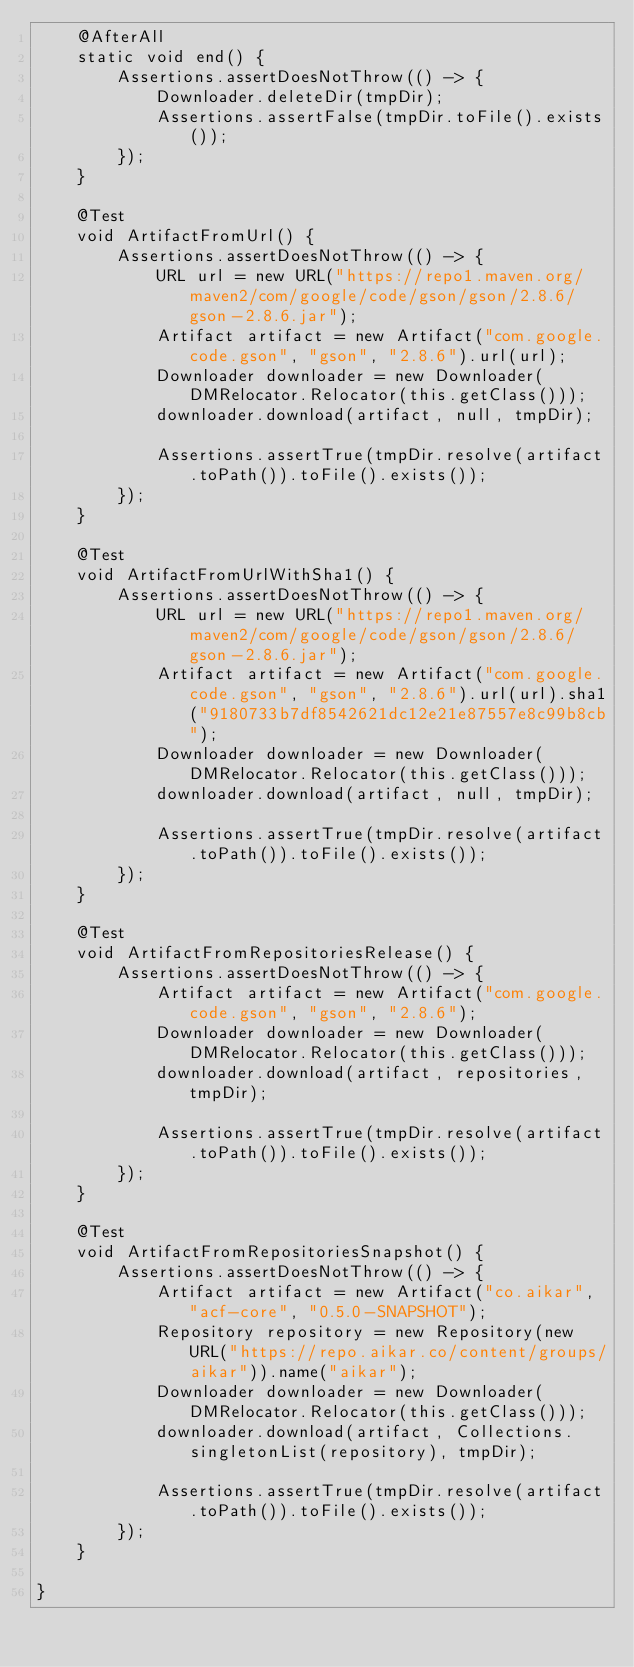<code> <loc_0><loc_0><loc_500><loc_500><_Java_>    @AfterAll
    static void end() {
        Assertions.assertDoesNotThrow(() -> {
            Downloader.deleteDir(tmpDir);
            Assertions.assertFalse(tmpDir.toFile().exists());
        });
    }

    @Test
    void ArtifactFromUrl() {
        Assertions.assertDoesNotThrow(() -> {
            URL url = new URL("https://repo1.maven.org/maven2/com/google/code/gson/gson/2.8.6/gson-2.8.6.jar");
            Artifact artifact = new Artifact("com.google.code.gson", "gson", "2.8.6").url(url);
            Downloader downloader = new Downloader(DMRelocator.Relocator(this.getClass()));
            downloader.download(artifact, null, tmpDir);

            Assertions.assertTrue(tmpDir.resolve(artifact.toPath()).toFile().exists());
        });
    }

    @Test
    void ArtifactFromUrlWithSha1() {
        Assertions.assertDoesNotThrow(() -> {
            URL url = new URL("https://repo1.maven.org/maven2/com/google/code/gson/gson/2.8.6/gson-2.8.6.jar");
            Artifact artifact = new Artifact("com.google.code.gson", "gson", "2.8.6").url(url).sha1("9180733b7df8542621dc12e21e87557e8c99b8cb");
            Downloader downloader = new Downloader(DMRelocator.Relocator(this.getClass()));
            downloader.download(artifact, null, tmpDir);

            Assertions.assertTrue(tmpDir.resolve(artifact.toPath()).toFile().exists());
        });
    }

    @Test
    void ArtifactFromRepositoriesRelease() {
        Assertions.assertDoesNotThrow(() -> {
            Artifact artifact = new Artifact("com.google.code.gson", "gson", "2.8.6");
            Downloader downloader = new Downloader(DMRelocator.Relocator(this.getClass()));
            downloader.download(artifact, repositories, tmpDir);

            Assertions.assertTrue(tmpDir.resolve(artifact.toPath()).toFile().exists());
        });
    }

    @Test
    void ArtifactFromRepositoriesSnapshot() {
        Assertions.assertDoesNotThrow(() -> {
            Artifact artifact = new Artifact("co.aikar", "acf-core", "0.5.0-SNAPSHOT");
            Repository repository = new Repository(new URL("https://repo.aikar.co/content/groups/aikar")).name("aikar");
            Downloader downloader = new Downloader(DMRelocator.Relocator(this.getClass()));
            downloader.download(artifact, Collections.singletonList(repository), tmpDir);

            Assertions.assertTrue(tmpDir.resolve(artifact.toPath()).toFile().exists());
        });
    }

}</code> 